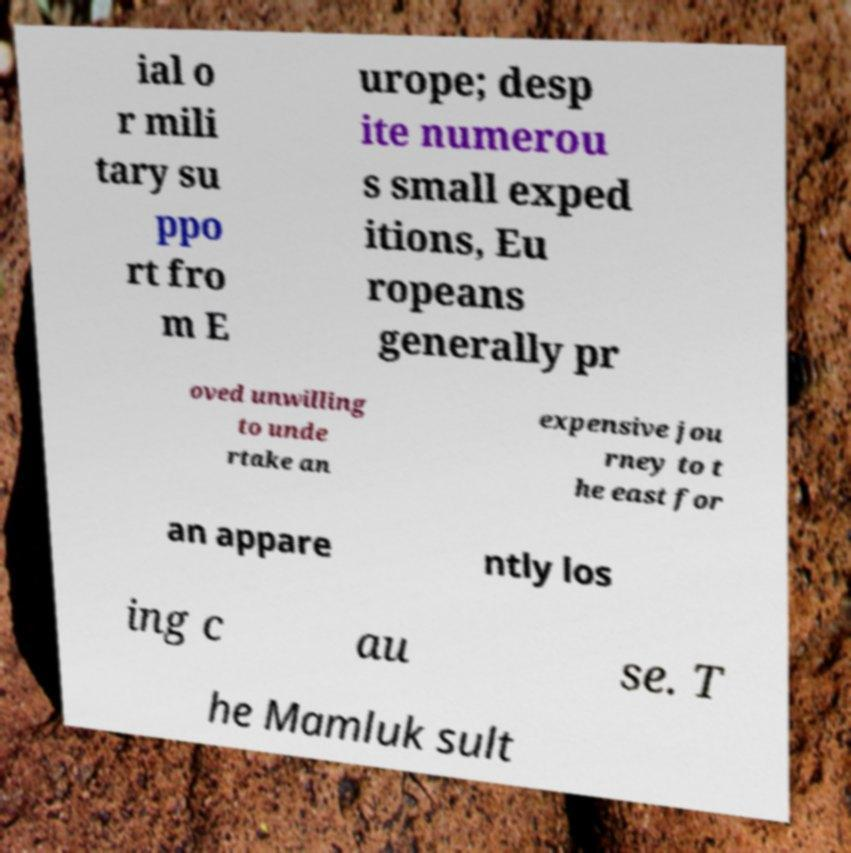Could you extract and type out the text from this image? ial o r mili tary su ppo rt fro m E urope; desp ite numerou s small exped itions, Eu ropeans generally pr oved unwilling to unde rtake an expensive jou rney to t he east for an appare ntly los ing c au se. T he Mamluk sult 